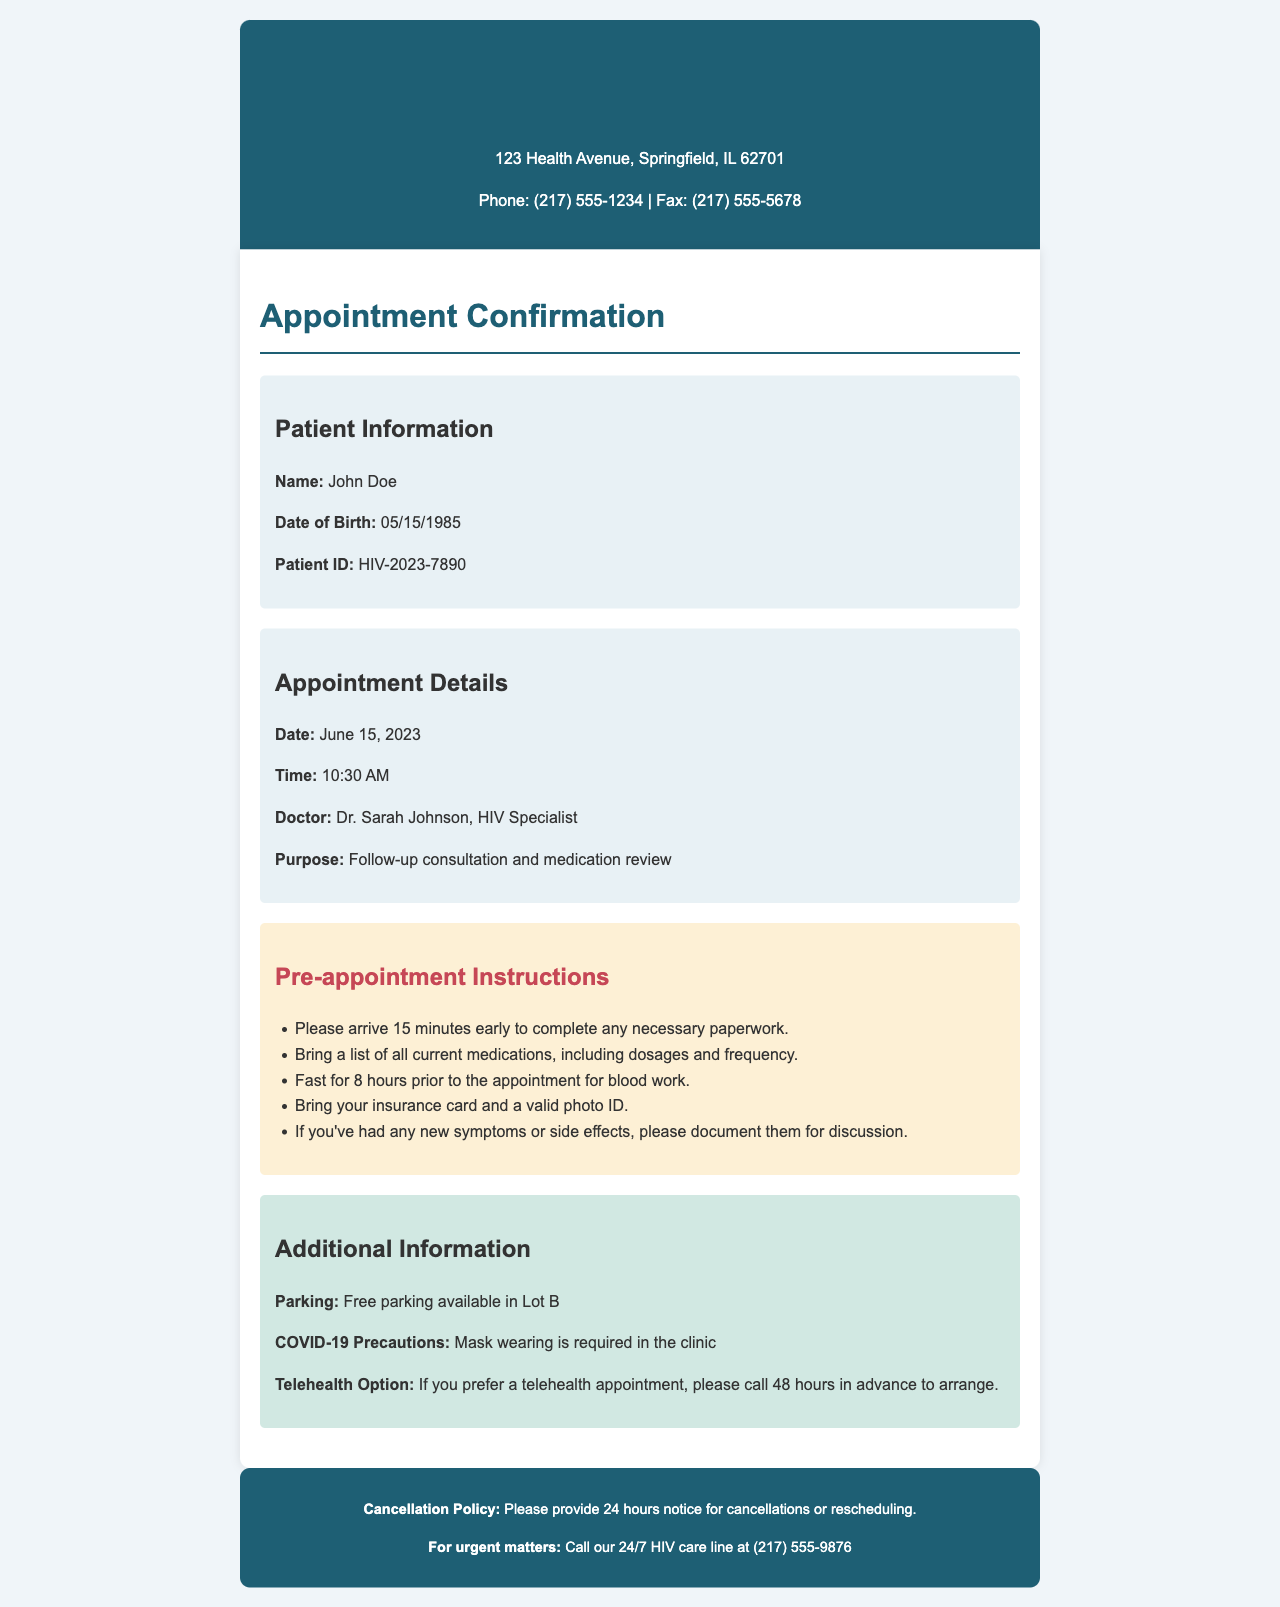What is the appointment date? The appointment date is stated in the appointment details section of the document.
Answer: June 15, 2023 Who is the HIV specialist? The name of the doctor is mentioned in the appointment details section.
Answer: Dr. Sarah Johnson What time is the appointment scheduled for? The appointment time is provided in the appointment details section of the document.
Answer: 10:30 AM What should a patient bring to the appointment? The pre-appointment instructions specify what items to bring for the appointment.
Answer: List of all current medications How long should a patient fast before the appointment? The fasting requirement is mentioned in the pre-appointment instructions.
Answer: 8 hours What is the purpose of the appointment? The purpose is stated in the appointment details in the document.
Answer: Follow-up consultation and medication review What is the cancellation policy? The document includes a cancellation policy towards the end.
Answer: 24 hours notice for cancellations Is there a telehealth option available? The additional information section mentions the telehealth option.
Answer: Yes What precautions are required due to COVID-19? COVID-19 precautions are specified in the additional information section of the document.
Answer: Mask wearing is required 